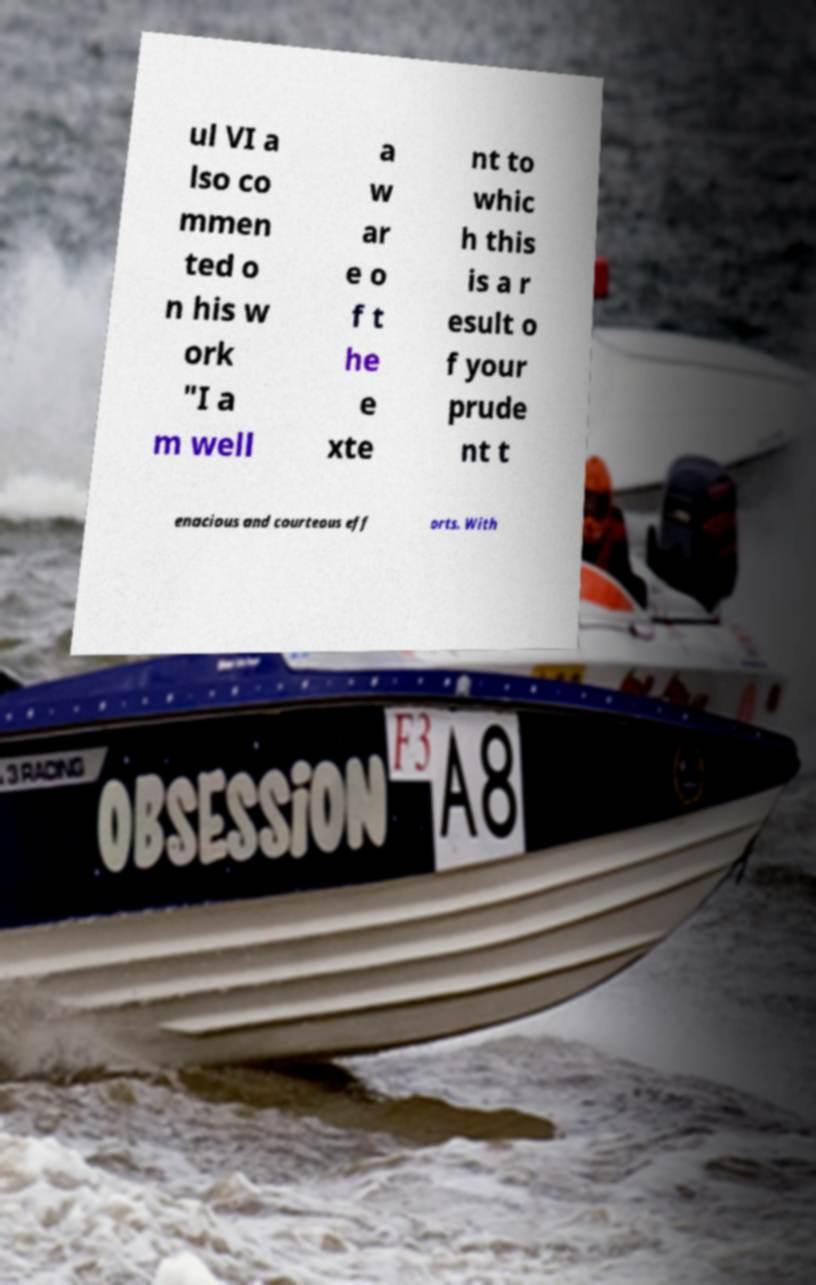Could you extract and type out the text from this image? ul VI a lso co mmen ted o n his w ork "I a m well a w ar e o f t he e xte nt to whic h this is a r esult o f your prude nt t enacious and courteous eff orts. With 